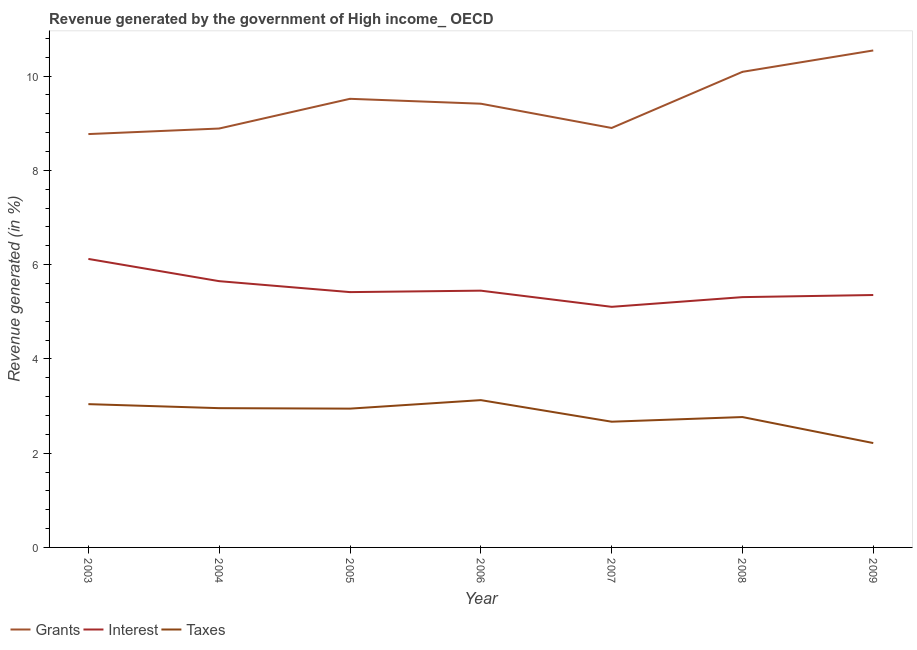How many different coloured lines are there?
Offer a very short reply. 3. Does the line corresponding to percentage of revenue generated by interest intersect with the line corresponding to percentage of revenue generated by grants?
Provide a succinct answer. No. What is the percentage of revenue generated by grants in 2009?
Provide a succinct answer. 10.54. Across all years, what is the maximum percentage of revenue generated by grants?
Provide a short and direct response. 10.54. Across all years, what is the minimum percentage of revenue generated by taxes?
Ensure brevity in your answer.  2.21. In which year was the percentage of revenue generated by grants maximum?
Provide a short and direct response. 2009. In which year was the percentage of revenue generated by taxes minimum?
Offer a terse response. 2009. What is the total percentage of revenue generated by grants in the graph?
Offer a very short reply. 66.12. What is the difference between the percentage of revenue generated by grants in 2006 and that in 2007?
Your answer should be compact. 0.51. What is the difference between the percentage of revenue generated by grants in 2007 and the percentage of revenue generated by taxes in 2003?
Your answer should be compact. 5.86. What is the average percentage of revenue generated by taxes per year?
Offer a terse response. 2.82. In the year 2005, what is the difference between the percentage of revenue generated by interest and percentage of revenue generated by taxes?
Offer a terse response. 2.47. In how many years, is the percentage of revenue generated by interest greater than 8 %?
Provide a succinct answer. 0. What is the ratio of the percentage of revenue generated by taxes in 2003 to that in 2004?
Your answer should be very brief. 1.03. Is the percentage of revenue generated by taxes in 2008 less than that in 2009?
Provide a succinct answer. No. What is the difference between the highest and the second highest percentage of revenue generated by grants?
Your response must be concise. 0.45. What is the difference between the highest and the lowest percentage of revenue generated by taxes?
Ensure brevity in your answer.  0.91. Is the percentage of revenue generated by grants strictly greater than the percentage of revenue generated by interest over the years?
Provide a short and direct response. Yes. Is the percentage of revenue generated by taxes strictly less than the percentage of revenue generated by grants over the years?
Provide a succinct answer. Yes. How many lines are there?
Provide a short and direct response. 3. How many years are there in the graph?
Provide a succinct answer. 7. What is the difference between two consecutive major ticks on the Y-axis?
Provide a short and direct response. 2. What is the title of the graph?
Offer a very short reply. Revenue generated by the government of High income_ OECD. Does "Self-employed" appear as one of the legend labels in the graph?
Your answer should be very brief. No. What is the label or title of the X-axis?
Make the answer very short. Year. What is the label or title of the Y-axis?
Offer a terse response. Revenue generated (in %). What is the Revenue generated (in %) of Grants in 2003?
Provide a succinct answer. 8.77. What is the Revenue generated (in %) of Interest in 2003?
Your response must be concise. 6.12. What is the Revenue generated (in %) in Taxes in 2003?
Provide a succinct answer. 3.04. What is the Revenue generated (in %) in Grants in 2004?
Make the answer very short. 8.89. What is the Revenue generated (in %) of Interest in 2004?
Provide a succinct answer. 5.65. What is the Revenue generated (in %) in Taxes in 2004?
Provide a short and direct response. 2.95. What is the Revenue generated (in %) in Grants in 2005?
Ensure brevity in your answer.  9.52. What is the Revenue generated (in %) of Interest in 2005?
Offer a very short reply. 5.42. What is the Revenue generated (in %) in Taxes in 2005?
Keep it short and to the point. 2.94. What is the Revenue generated (in %) of Grants in 2006?
Provide a succinct answer. 9.41. What is the Revenue generated (in %) in Interest in 2006?
Provide a succinct answer. 5.45. What is the Revenue generated (in %) in Taxes in 2006?
Give a very brief answer. 3.12. What is the Revenue generated (in %) in Grants in 2007?
Your response must be concise. 8.9. What is the Revenue generated (in %) in Interest in 2007?
Your response must be concise. 5.1. What is the Revenue generated (in %) in Taxes in 2007?
Give a very brief answer. 2.67. What is the Revenue generated (in %) in Grants in 2008?
Your answer should be very brief. 10.09. What is the Revenue generated (in %) in Interest in 2008?
Your answer should be compact. 5.31. What is the Revenue generated (in %) of Taxes in 2008?
Your answer should be very brief. 2.77. What is the Revenue generated (in %) of Grants in 2009?
Your answer should be very brief. 10.54. What is the Revenue generated (in %) of Interest in 2009?
Ensure brevity in your answer.  5.35. What is the Revenue generated (in %) in Taxes in 2009?
Keep it short and to the point. 2.21. Across all years, what is the maximum Revenue generated (in %) in Grants?
Your answer should be compact. 10.54. Across all years, what is the maximum Revenue generated (in %) in Interest?
Keep it short and to the point. 6.12. Across all years, what is the maximum Revenue generated (in %) in Taxes?
Offer a very short reply. 3.12. Across all years, what is the minimum Revenue generated (in %) of Grants?
Ensure brevity in your answer.  8.77. Across all years, what is the minimum Revenue generated (in %) in Interest?
Your answer should be very brief. 5.1. Across all years, what is the minimum Revenue generated (in %) of Taxes?
Your answer should be compact. 2.21. What is the total Revenue generated (in %) of Grants in the graph?
Your response must be concise. 66.12. What is the total Revenue generated (in %) of Interest in the graph?
Your response must be concise. 38.4. What is the total Revenue generated (in %) in Taxes in the graph?
Offer a terse response. 19.71. What is the difference between the Revenue generated (in %) in Grants in 2003 and that in 2004?
Offer a very short reply. -0.12. What is the difference between the Revenue generated (in %) in Interest in 2003 and that in 2004?
Offer a terse response. 0.47. What is the difference between the Revenue generated (in %) in Taxes in 2003 and that in 2004?
Offer a very short reply. 0.09. What is the difference between the Revenue generated (in %) in Grants in 2003 and that in 2005?
Offer a terse response. -0.75. What is the difference between the Revenue generated (in %) in Interest in 2003 and that in 2005?
Your answer should be very brief. 0.7. What is the difference between the Revenue generated (in %) of Taxes in 2003 and that in 2005?
Offer a terse response. 0.1. What is the difference between the Revenue generated (in %) in Grants in 2003 and that in 2006?
Provide a succinct answer. -0.64. What is the difference between the Revenue generated (in %) of Interest in 2003 and that in 2006?
Ensure brevity in your answer.  0.67. What is the difference between the Revenue generated (in %) in Taxes in 2003 and that in 2006?
Ensure brevity in your answer.  -0.09. What is the difference between the Revenue generated (in %) in Grants in 2003 and that in 2007?
Offer a terse response. -0.13. What is the difference between the Revenue generated (in %) of Interest in 2003 and that in 2007?
Keep it short and to the point. 1.02. What is the difference between the Revenue generated (in %) in Taxes in 2003 and that in 2007?
Offer a very short reply. 0.37. What is the difference between the Revenue generated (in %) of Grants in 2003 and that in 2008?
Offer a very short reply. -1.32. What is the difference between the Revenue generated (in %) in Interest in 2003 and that in 2008?
Provide a short and direct response. 0.81. What is the difference between the Revenue generated (in %) in Taxes in 2003 and that in 2008?
Provide a short and direct response. 0.27. What is the difference between the Revenue generated (in %) in Grants in 2003 and that in 2009?
Your answer should be very brief. -1.77. What is the difference between the Revenue generated (in %) in Interest in 2003 and that in 2009?
Provide a short and direct response. 0.77. What is the difference between the Revenue generated (in %) in Taxes in 2003 and that in 2009?
Give a very brief answer. 0.83. What is the difference between the Revenue generated (in %) of Grants in 2004 and that in 2005?
Ensure brevity in your answer.  -0.63. What is the difference between the Revenue generated (in %) in Interest in 2004 and that in 2005?
Give a very brief answer. 0.23. What is the difference between the Revenue generated (in %) in Taxes in 2004 and that in 2005?
Make the answer very short. 0.01. What is the difference between the Revenue generated (in %) in Grants in 2004 and that in 2006?
Keep it short and to the point. -0.53. What is the difference between the Revenue generated (in %) of Interest in 2004 and that in 2006?
Offer a very short reply. 0.2. What is the difference between the Revenue generated (in %) in Taxes in 2004 and that in 2006?
Keep it short and to the point. -0.17. What is the difference between the Revenue generated (in %) of Grants in 2004 and that in 2007?
Offer a terse response. -0.01. What is the difference between the Revenue generated (in %) in Interest in 2004 and that in 2007?
Offer a terse response. 0.54. What is the difference between the Revenue generated (in %) in Taxes in 2004 and that in 2007?
Your response must be concise. 0.29. What is the difference between the Revenue generated (in %) of Grants in 2004 and that in 2008?
Give a very brief answer. -1.2. What is the difference between the Revenue generated (in %) in Interest in 2004 and that in 2008?
Your response must be concise. 0.34. What is the difference between the Revenue generated (in %) of Taxes in 2004 and that in 2008?
Your answer should be compact. 0.19. What is the difference between the Revenue generated (in %) of Grants in 2004 and that in 2009?
Provide a short and direct response. -1.66. What is the difference between the Revenue generated (in %) of Interest in 2004 and that in 2009?
Offer a very short reply. 0.29. What is the difference between the Revenue generated (in %) of Taxes in 2004 and that in 2009?
Offer a very short reply. 0.74. What is the difference between the Revenue generated (in %) of Grants in 2005 and that in 2006?
Your answer should be very brief. 0.1. What is the difference between the Revenue generated (in %) of Interest in 2005 and that in 2006?
Your response must be concise. -0.03. What is the difference between the Revenue generated (in %) in Taxes in 2005 and that in 2006?
Your response must be concise. -0.18. What is the difference between the Revenue generated (in %) in Grants in 2005 and that in 2007?
Provide a succinct answer. 0.62. What is the difference between the Revenue generated (in %) in Interest in 2005 and that in 2007?
Your response must be concise. 0.31. What is the difference between the Revenue generated (in %) in Taxes in 2005 and that in 2007?
Your answer should be very brief. 0.28. What is the difference between the Revenue generated (in %) in Grants in 2005 and that in 2008?
Keep it short and to the point. -0.57. What is the difference between the Revenue generated (in %) in Interest in 2005 and that in 2008?
Provide a short and direct response. 0.11. What is the difference between the Revenue generated (in %) in Taxes in 2005 and that in 2008?
Make the answer very short. 0.18. What is the difference between the Revenue generated (in %) in Grants in 2005 and that in 2009?
Keep it short and to the point. -1.03. What is the difference between the Revenue generated (in %) of Interest in 2005 and that in 2009?
Your answer should be compact. 0.06. What is the difference between the Revenue generated (in %) in Taxes in 2005 and that in 2009?
Provide a short and direct response. 0.73. What is the difference between the Revenue generated (in %) of Grants in 2006 and that in 2007?
Your answer should be very brief. 0.51. What is the difference between the Revenue generated (in %) in Interest in 2006 and that in 2007?
Keep it short and to the point. 0.34. What is the difference between the Revenue generated (in %) of Taxes in 2006 and that in 2007?
Keep it short and to the point. 0.46. What is the difference between the Revenue generated (in %) of Grants in 2006 and that in 2008?
Your answer should be compact. -0.68. What is the difference between the Revenue generated (in %) of Interest in 2006 and that in 2008?
Ensure brevity in your answer.  0.14. What is the difference between the Revenue generated (in %) in Taxes in 2006 and that in 2008?
Provide a succinct answer. 0.36. What is the difference between the Revenue generated (in %) in Grants in 2006 and that in 2009?
Offer a very short reply. -1.13. What is the difference between the Revenue generated (in %) of Interest in 2006 and that in 2009?
Make the answer very short. 0.09. What is the difference between the Revenue generated (in %) of Taxes in 2006 and that in 2009?
Provide a succinct answer. 0.91. What is the difference between the Revenue generated (in %) in Grants in 2007 and that in 2008?
Your response must be concise. -1.19. What is the difference between the Revenue generated (in %) of Interest in 2007 and that in 2008?
Provide a succinct answer. -0.21. What is the difference between the Revenue generated (in %) in Taxes in 2007 and that in 2008?
Your response must be concise. -0.1. What is the difference between the Revenue generated (in %) of Grants in 2007 and that in 2009?
Your response must be concise. -1.64. What is the difference between the Revenue generated (in %) of Interest in 2007 and that in 2009?
Keep it short and to the point. -0.25. What is the difference between the Revenue generated (in %) of Taxes in 2007 and that in 2009?
Keep it short and to the point. 0.45. What is the difference between the Revenue generated (in %) of Grants in 2008 and that in 2009?
Your answer should be very brief. -0.45. What is the difference between the Revenue generated (in %) in Interest in 2008 and that in 2009?
Give a very brief answer. -0.04. What is the difference between the Revenue generated (in %) of Taxes in 2008 and that in 2009?
Ensure brevity in your answer.  0.55. What is the difference between the Revenue generated (in %) of Grants in 2003 and the Revenue generated (in %) of Interest in 2004?
Your answer should be compact. 3.12. What is the difference between the Revenue generated (in %) in Grants in 2003 and the Revenue generated (in %) in Taxes in 2004?
Your answer should be compact. 5.81. What is the difference between the Revenue generated (in %) in Interest in 2003 and the Revenue generated (in %) in Taxes in 2004?
Provide a short and direct response. 3.17. What is the difference between the Revenue generated (in %) in Grants in 2003 and the Revenue generated (in %) in Interest in 2005?
Ensure brevity in your answer.  3.35. What is the difference between the Revenue generated (in %) in Grants in 2003 and the Revenue generated (in %) in Taxes in 2005?
Make the answer very short. 5.82. What is the difference between the Revenue generated (in %) in Interest in 2003 and the Revenue generated (in %) in Taxes in 2005?
Your answer should be very brief. 3.18. What is the difference between the Revenue generated (in %) in Grants in 2003 and the Revenue generated (in %) in Interest in 2006?
Ensure brevity in your answer.  3.32. What is the difference between the Revenue generated (in %) in Grants in 2003 and the Revenue generated (in %) in Taxes in 2006?
Provide a short and direct response. 5.64. What is the difference between the Revenue generated (in %) in Interest in 2003 and the Revenue generated (in %) in Taxes in 2006?
Keep it short and to the point. 3. What is the difference between the Revenue generated (in %) of Grants in 2003 and the Revenue generated (in %) of Interest in 2007?
Provide a short and direct response. 3.66. What is the difference between the Revenue generated (in %) in Grants in 2003 and the Revenue generated (in %) in Taxes in 2007?
Ensure brevity in your answer.  6.1. What is the difference between the Revenue generated (in %) of Interest in 2003 and the Revenue generated (in %) of Taxes in 2007?
Keep it short and to the point. 3.45. What is the difference between the Revenue generated (in %) of Grants in 2003 and the Revenue generated (in %) of Interest in 2008?
Provide a succinct answer. 3.46. What is the difference between the Revenue generated (in %) of Grants in 2003 and the Revenue generated (in %) of Taxes in 2008?
Offer a terse response. 6. What is the difference between the Revenue generated (in %) of Interest in 2003 and the Revenue generated (in %) of Taxes in 2008?
Ensure brevity in your answer.  3.35. What is the difference between the Revenue generated (in %) in Grants in 2003 and the Revenue generated (in %) in Interest in 2009?
Your answer should be very brief. 3.41. What is the difference between the Revenue generated (in %) of Grants in 2003 and the Revenue generated (in %) of Taxes in 2009?
Your answer should be very brief. 6.55. What is the difference between the Revenue generated (in %) of Interest in 2003 and the Revenue generated (in %) of Taxes in 2009?
Provide a succinct answer. 3.91. What is the difference between the Revenue generated (in %) of Grants in 2004 and the Revenue generated (in %) of Interest in 2005?
Provide a succinct answer. 3.47. What is the difference between the Revenue generated (in %) in Grants in 2004 and the Revenue generated (in %) in Taxes in 2005?
Your response must be concise. 5.94. What is the difference between the Revenue generated (in %) in Interest in 2004 and the Revenue generated (in %) in Taxes in 2005?
Offer a terse response. 2.7. What is the difference between the Revenue generated (in %) in Grants in 2004 and the Revenue generated (in %) in Interest in 2006?
Offer a terse response. 3.44. What is the difference between the Revenue generated (in %) of Grants in 2004 and the Revenue generated (in %) of Taxes in 2006?
Keep it short and to the point. 5.76. What is the difference between the Revenue generated (in %) of Interest in 2004 and the Revenue generated (in %) of Taxes in 2006?
Offer a very short reply. 2.52. What is the difference between the Revenue generated (in %) of Grants in 2004 and the Revenue generated (in %) of Interest in 2007?
Offer a terse response. 3.78. What is the difference between the Revenue generated (in %) in Grants in 2004 and the Revenue generated (in %) in Taxes in 2007?
Give a very brief answer. 6.22. What is the difference between the Revenue generated (in %) in Interest in 2004 and the Revenue generated (in %) in Taxes in 2007?
Your response must be concise. 2.98. What is the difference between the Revenue generated (in %) of Grants in 2004 and the Revenue generated (in %) of Interest in 2008?
Give a very brief answer. 3.58. What is the difference between the Revenue generated (in %) of Grants in 2004 and the Revenue generated (in %) of Taxes in 2008?
Offer a terse response. 6.12. What is the difference between the Revenue generated (in %) in Interest in 2004 and the Revenue generated (in %) in Taxes in 2008?
Your answer should be very brief. 2.88. What is the difference between the Revenue generated (in %) in Grants in 2004 and the Revenue generated (in %) in Interest in 2009?
Keep it short and to the point. 3.53. What is the difference between the Revenue generated (in %) of Grants in 2004 and the Revenue generated (in %) of Taxes in 2009?
Make the answer very short. 6.67. What is the difference between the Revenue generated (in %) in Interest in 2004 and the Revenue generated (in %) in Taxes in 2009?
Your answer should be compact. 3.43. What is the difference between the Revenue generated (in %) of Grants in 2005 and the Revenue generated (in %) of Interest in 2006?
Make the answer very short. 4.07. What is the difference between the Revenue generated (in %) of Grants in 2005 and the Revenue generated (in %) of Taxes in 2006?
Offer a very short reply. 6.39. What is the difference between the Revenue generated (in %) of Interest in 2005 and the Revenue generated (in %) of Taxes in 2006?
Provide a succinct answer. 2.29. What is the difference between the Revenue generated (in %) of Grants in 2005 and the Revenue generated (in %) of Interest in 2007?
Ensure brevity in your answer.  4.41. What is the difference between the Revenue generated (in %) in Grants in 2005 and the Revenue generated (in %) in Taxes in 2007?
Give a very brief answer. 6.85. What is the difference between the Revenue generated (in %) in Interest in 2005 and the Revenue generated (in %) in Taxes in 2007?
Your answer should be very brief. 2.75. What is the difference between the Revenue generated (in %) in Grants in 2005 and the Revenue generated (in %) in Interest in 2008?
Provide a succinct answer. 4.21. What is the difference between the Revenue generated (in %) of Grants in 2005 and the Revenue generated (in %) of Taxes in 2008?
Offer a terse response. 6.75. What is the difference between the Revenue generated (in %) of Interest in 2005 and the Revenue generated (in %) of Taxes in 2008?
Keep it short and to the point. 2.65. What is the difference between the Revenue generated (in %) of Grants in 2005 and the Revenue generated (in %) of Interest in 2009?
Your answer should be compact. 4.16. What is the difference between the Revenue generated (in %) in Grants in 2005 and the Revenue generated (in %) in Taxes in 2009?
Your answer should be very brief. 7.3. What is the difference between the Revenue generated (in %) in Interest in 2005 and the Revenue generated (in %) in Taxes in 2009?
Your response must be concise. 3.2. What is the difference between the Revenue generated (in %) of Grants in 2006 and the Revenue generated (in %) of Interest in 2007?
Your answer should be very brief. 4.31. What is the difference between the Revenue generated (in %) in Grants in 2006 and the Revenue generated (in %) in Taxes in 2007?
Your answer should be very brief. 6.75. What is the difference between the Revenue generated (in %) of Interest in 2006 and the Revenue generated (in %) of Taxes in 2007?
Your response must be concise. 2.78. What is the difference between the Revenue generated (in %) of Grants in 2006 and the Revenue generated (in %) of Interest in 2008?
Offer a very short reply. 4.1. What is the difference between the Revenue generated (in %) in Grants in 2006 and the Revenue generated (in %) in Taxes in 2008?
Your answer should be very brief. 6.65. What is the difference between the Revenue generated (in %) in Interest in 2006 and the Revenue generated (in %) in Taxes in 2008?
Your response must be concise. 2.68. What is the difference between the Revenue generated (in %) of Grants in 2006 and the Revenue generated (in %) of Interest in 2009?
Make the answer very short. 4.06. What is the difference between the Revenue generated (in %) in Grants in 2006 and the Revenue generated (in %) in Taxes in 2009?
Provide a short and direct response. 7.2. What is the difference between the Revenue generated (in %) in Interest in 2006 and the Revenue generated (in %) in Taxes in 2009?
Give a very brief answer. 3.23. What is the difference between the Revenue generated (in %) in Grants in 2007 and the Revenue generated (in %) in Interest in 2008?
Make the answer very short. 3.59. What is the difference between the Revenue generated (in %) in Grants in 2007 and the Revenue generated (in %) in Taxes in 2008?
Offer a very short reply. 6.13. What is the difference between the Revenue generated (in %) in Interest in 2007 and the Revenue generated (in %) in Taxes in 2008?
Give a very brief answer. 2.34. What is the difference between the Revenue generated (in %) of Grants in 2007 and the Revenue generated (in %) of Interest in 2009?
Your answer should be very brief. 3.54. What is the difference between the Revenue generated (in %) of Grants in 2007 and the Revenue generated (in %) of Taxes in 2009?
Ensure brevity in your answer.  6.68. What is the difference between the Revenue generated (in %) in Interest in 2007 and the Revenue generated (in %) in Taxes in 2009?
Provide a short and direct response. 2.89. What is the difference between the Revenue generated (in %) in Grants in 2008 and the Revenue generated (in %) in Interest in 2009?
Offer a terse response. 4.73. What is the difference between the Revenue generated (in %) of Grants in 2008 and the Revenue generated (in %) of Taxes in 2009?
Provide a short and direct response. 7.88. What is the difference between the Revenue generated (in %) in Interest in 2008 and the Revenue generated (in %) in Taxes in 2009?
Your response must be concise. 3.1. What is the average Revenue generated (in %) in Grants per year?
Offer a terse response. 9.45. What is the average Revenue generated (in %) in Interest per year?
Offer a terse response. 5.49. What is the average Revenue generated (in %) in Taxes per year?
Ensure brevity in your answer.  2.82. In the year 2003, what is the difference between the Revenue generated (in %) in Grants and Revenue generated (in %) in Interest?
Provide a short and direct response. 2.65. In the year 2003, what is the difference between the Revenue generated (in %) in Grants and Revenue generated (in %) in Taxes?
Keep it short and to the point. 5.73. In the year 2003, what is the difference between the Revenue generated (in %) of Interest and Revenue generated (in %) of Taxes?
Give a very brief answer. 3.08. In the year 2004, what is the difference between the Revenue generated (in %) of Grants and Revenue generated (in %) of Interest?
Ensure brevity in your answer.  3.24. In the year 2004, what is the difference between the Revenue generated (in %) in Grants and Revenue generated (in %) in Taxes?
Provide a succinct answer. 5.93. In the year 2004, what is the difference between the Revenue generated (in %) in Interest and Revenue generated (in %) in Taxes?
Provide a succinct answer. 2.69. In the year 2005, what is the difference between the Revenue generated (in %) of Grants and Revenue generated (in %) of Interest?
Offer a terse response. 4.1. In the year 2005, what is the difference between the Revenue generated (in %) of Grants and Revenue generated (in %) of Taxes?
Offer a very short reply. 6.57. In the year 2005, what is the difference between the Revenue generated (in %) in Interest and Revenue generated (in %) in Taxes?
Offer a terse response. 2.47. In the year 2006, what is the difference between the Revenue generated (in %) in Grants and Revenue generated (in %) in Interest?
Your answer should be compact. 3.97. In the year 2006, what is the difference between the Revenue generated (in %) of Grants and Revenue generated (in %) of Taxes?
Ensure brevity in your answer.  6.29. In the year 2006, what is the difference between the Revenue generated (in %) of Interest and Revenue generated (in %) of Taxes?
Make the answer very short. 2.32. In the year 2007, what is the difference between the Revenue generated (in %) in Grants and Revenue generated (in %) in Interest?
Provide a succinct answer. 3.79. In the year 2007, what is the difference between the Revenue generated (in %) of Grants and Revenue generated (in %) of Taxes?
Give a very brief answer. 6.23. In the year 2007, what is the difference between the Revenue generated (in %) in Interest and Revenue generated (in %) in Taxes?
Offer a very short reply. 2.44. In the year 2008, what is the difference between the Revenue generated (in %) in Grants and Revenue generated (in %) in Interest?
Your answer should be compact. 4.78. In the year 2008, what is the difference between the Revenue generated (in %) in Grants and Revenue generated (in %) in Taxes?
Keep it short and to the point. 7.32. In the year 2008, what is the difference between the Revenue generated (in %) in Interest and Revenue generated (in %) in Taxes?
Your answer should be very brief. 2.54. In the year 2009, what is the difference between the Revenue generated (in %) in Grants and Revenue generated (in %) in Interest?
Offer a terse response. 5.19. In the year 2009, what is the difference between the Revenue generated (in %) of Grants and Revenue generated (in %) of Taxes?
Provide a succinct answer. 8.33. In the year 2009, what is the difference between the Revenue generated (in %) in Interest and Revenue generated (in %) in Taxes?
Offer a very short reply. 3.14. What is the ratio of the Revenue generated (in %) of Grants in 2003 to that in 2004?
Your response must be concise. 0.99. What is the ratio of the Revenue generated (in %) in Interest in 2003 to that in 2004?
Keep it short and to the point. 1.08. What is the ratio of the Revenue generated (in %) of Taxes in 2003 to that in 2004?
Make the answer very short. 1.03. What is the ratio of the Revenue generated (in %) in Grants in 2003 to that in 2005?
Ensure brevity in your answer.  0.92. What is the ratio of the Revenue generated (in %) of Interest in 2003 to that in 2005?
Make the answer very short. 1.13. What is the ratio of the Revenue generated (in %) in Taxes in 2003 to that in 2005?
Offer a terse response. 1.03. What is the ratio of the Revenue generated (in %) of Grants in 2003 to that in 2006?
Offer a terse response. 0.93. What is the ratio of the Revenue generated (in %) of Interest in 2003 to that in 2006?
Give a very brief answer. 1.12. What is the ratio of the Revenue generated (in %) of Taxes in 2003 to that in 2006?
Make the answer very short. 0.97. What is the ratio of the Revenue generated (in %) of Grants in 2003 to that in 2007?
Offer a very short reply. 0.99. What is the ratio of the Revenue generated (in %) of Interest in 2003 to that in 2007?
Make the answer very short. 1.2. What is the ratio of the Revenue generated (in %) of Taxes in 2003 to that in 2007?
Offer a terse response. 1.14. What is the ratio of the Revenue generated (in %) of Grants in 2003 to that in 2008?
Provide a short and direct response. 0.87. What is the ratio of the Revenue generated (in %) in Interest in 2003 to that in 2008?
Offer a very short reply. 1.15. What is the ratio of the Revenue generated (in %) of Taxes in 2003 to that in 2008?
Your answer should be compact. 1.1. What is the ratio of the Revenue generated (in %) of Grants in 2003 to that in 2009?
Keep it short and to the point. 0.83. What is the ratio of the Revenue generated (in %) of Interest in 2003 to that in 2009?
Keep it short and to the point. 1.14. What is the ratio of the Revenue generated (in %) of Taxes in 2003 to that in 2009?
Your answer should be very brief. 1.37. What is the ratio of the Revenue generated (in %) of Grants in 2004 to that in 2005?
Keep it short and to the point. 0.93. What is the ratio of the Revenue generated (in %) of Interest in 2004 to that in 2005?
Offer a terse response. 1.04. What is the ratio of the Revenue generated (in %) in Grants in 2004 to that in 2006?
Provide a succinct answer. 0.94. What is the ratio of the Revenue generated (in %) of Taxes in 2004 to that in 2006?
Offer a very short reply. 0.95. What is the ratio of the Revenue generated (in %) in Grants in 2004 to that in 2007?
Offer a terse response. 1. What is the ratio of the Revenue generated (in %) in Interest in 2004 to that in 2007?
Your answer should be very brief. 1.11. What is the ratio of the Revenue generated (in %) of Taxes in 2004 to that in 2007?
Make the answer very short. 1.11. What is the ratio of the Revenue generated (in %) of Grants in 2004 to that in 2008?
Give a very brief answer. 0.88. What is the ratio of the Revenue generated (in %) of Interest in 2004 to that in 2008?
Your answer should be very brief. 1.06. What is the ratio of the Revenue generated (in %) of Taxes in 2004 to that in 2008?
Offer a terse response. 1.07. What is the ratio of the Revenue generated (in %) of Grants in 2004 to that in 2009?
Offer a very short reply. 0.84. What is the ratio of the Revenue generated (in %) in Interest in 2004 to that in 2009?
Offer a very short reply. 1.05. What is the ratio of the Revenue generated (in %) in Taxes in 2004 to that in 2009?
Keep it short and to the point. 1.33. What is the ratio of the Revenue generated (in %) of Grants in 2005 to that in 2006?
Ensure brevity in your answer.  1.01. What is the ratio of the Revenue generated (in %) in Taxes in 2005 to that in 2006?
Ensure brevity in your answer.  0.94. What is the ratio of the Revenue generated (in %) of Grants in 2005 to that in 2007?
Give a very brief answer. 1.07. What is the ratio of the Revenue generated (in %) of Interest in 2005 to that in 2007?
Your answer should be very brief. 1.06. What is the ratio of the Revenue generated (in %) in Taxes in 2005 to that in 2007?
Offer a very short reply. 1.1. What is the ratio of the Revenue generated (in %) of Grants in 2005 to that in 2008?
Ensure brevity in your answer.  0.94. What is the ratio of the Revenue generated (in %) in Taxes in 2005 to that in 2008?
Give a very brief answer. 1.06. What is the ratio of the Revenue generated (in %) of Grants in 2005 to that in 2009?
Give a very brief answer. 0.9. What is the ratio of the Revenue generated (in %) in Interest in 2005 to that in 2009?
Provide a succinct answer. 1.01. What is the ratio of the Revenue generated (in %) in Taxes in 2005 to that in 2009?
Your answer should be very brief. 1.33. What is the ratio of the Revenue generated (in %) of Grants in 2006 to that in 2007?
Give a very brief answer. 1.06. What is the ratio of the Revenue generated (in %) of Interest in 2006 to that in 2007?
Your response must be concise. 1.07. What is the ratio of the Revenue generated (in %) in Taxes in 2006 to that in 2007?
Your answer should be compact. 1.17. What is the ratio of the Revenue generated (in %) of Grants in 2006 to that in 2008?
Your response must be concise. 0.93. What is the ratio of the Revenue generated (in %) of Interest in 2006 to that in 2008?
Provide a succinct answer. 1.03. What is the ratio of the Revenue generated (in %) of Taxes in 2006 to that in 2008?
Ensure brevity in your answer.  1.13. What is the ratio of the Revenue generated (in %) in Grants in 2006 to that in 2009?
Offer a very short reply. 0.89. What is the ratio of the Revenue generated (in %) of Interest in 2006 to that in 2009?
Ensure brevity in your answer.  1.02. What is the ratio of the Revenue generated (in %) of Taxes in 2006 to that in 2009?
Offer a terse response. 1.41. What is the ratio of the Revenue generated (in %) of Grants in 2007 to that in 2008?
Your answer should be very brief. 0.88. What is the ratio of the Revenue generated (in %) of Interest in 2007 to that in 2008?
Provide a succinct answer. 0.96. What is the ratio of the Revenue generated (in %) in Taxes in 2007 to that in 2008?
Give a very brief answer. 0.96. What is the ratio of the Revenue generated (in %) in Grants in 2007 to that in 2009?
Offer a very short reply. 0.84. What is the ratio of the Revenue generated (in %) of Interest in 2007 to that in 2009?
Your answer should be very brief. 0.95. What is the ratio of the Revenue generated (in %) in Taxes in 2007 to that in 2009?
Provide a succinct answer. 1.2. What is the ratio of the Revenue generated (in %) of Grants in 2008 to that in 2009?
Keep it short and to the point. 0.96. What is the ratio of the Revenue generated (in %) of Taxes in 2008 to that in 2009?
Give a very brief answer. 1.25. What is the difference between the highest and the second highest Revenue generated (in %) in Grants?
Keep it short and to the point. 0.45. What is the difference between the highest and the second highest Revenue generated (in %) of Interest?
Your response must be concise. 0.47. What is the difference between the highest and the second highest Revenue generated (in %) in Taxes?
Offer a terse response. 0.09. What is the difference between the highest and the lowest Revenue generated (in %) in Grants?
Offer a terse response. 1.77. What is the difference between the highest and the lowest Revenue generated (in %) of Interest?
Your answer should be very brief. 1.02. What is the difference between the highest and the lowest Revenue generated (in %) in Taxes?
Ensure brevity in your answer.  0.91. 